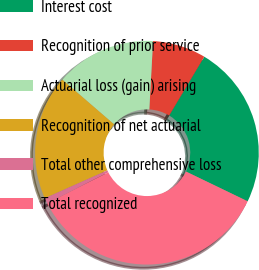<chart> <loc_0><loc_0><loc_500><loc_500><pie_chart><fcel>Interest cost<fcel>Recognition of prior service<fcel>Actuarial loss (gain) arising<fcel>Recognition of net actuarial<fcel>Total other comprehensive loss<fcel>Total recognized<nl><fcel>23.58%<fcel>7.7%<fcel>14.54%<fcel>18.0%<fcel>0.79%<fcel>35.38%<nl></chart> 